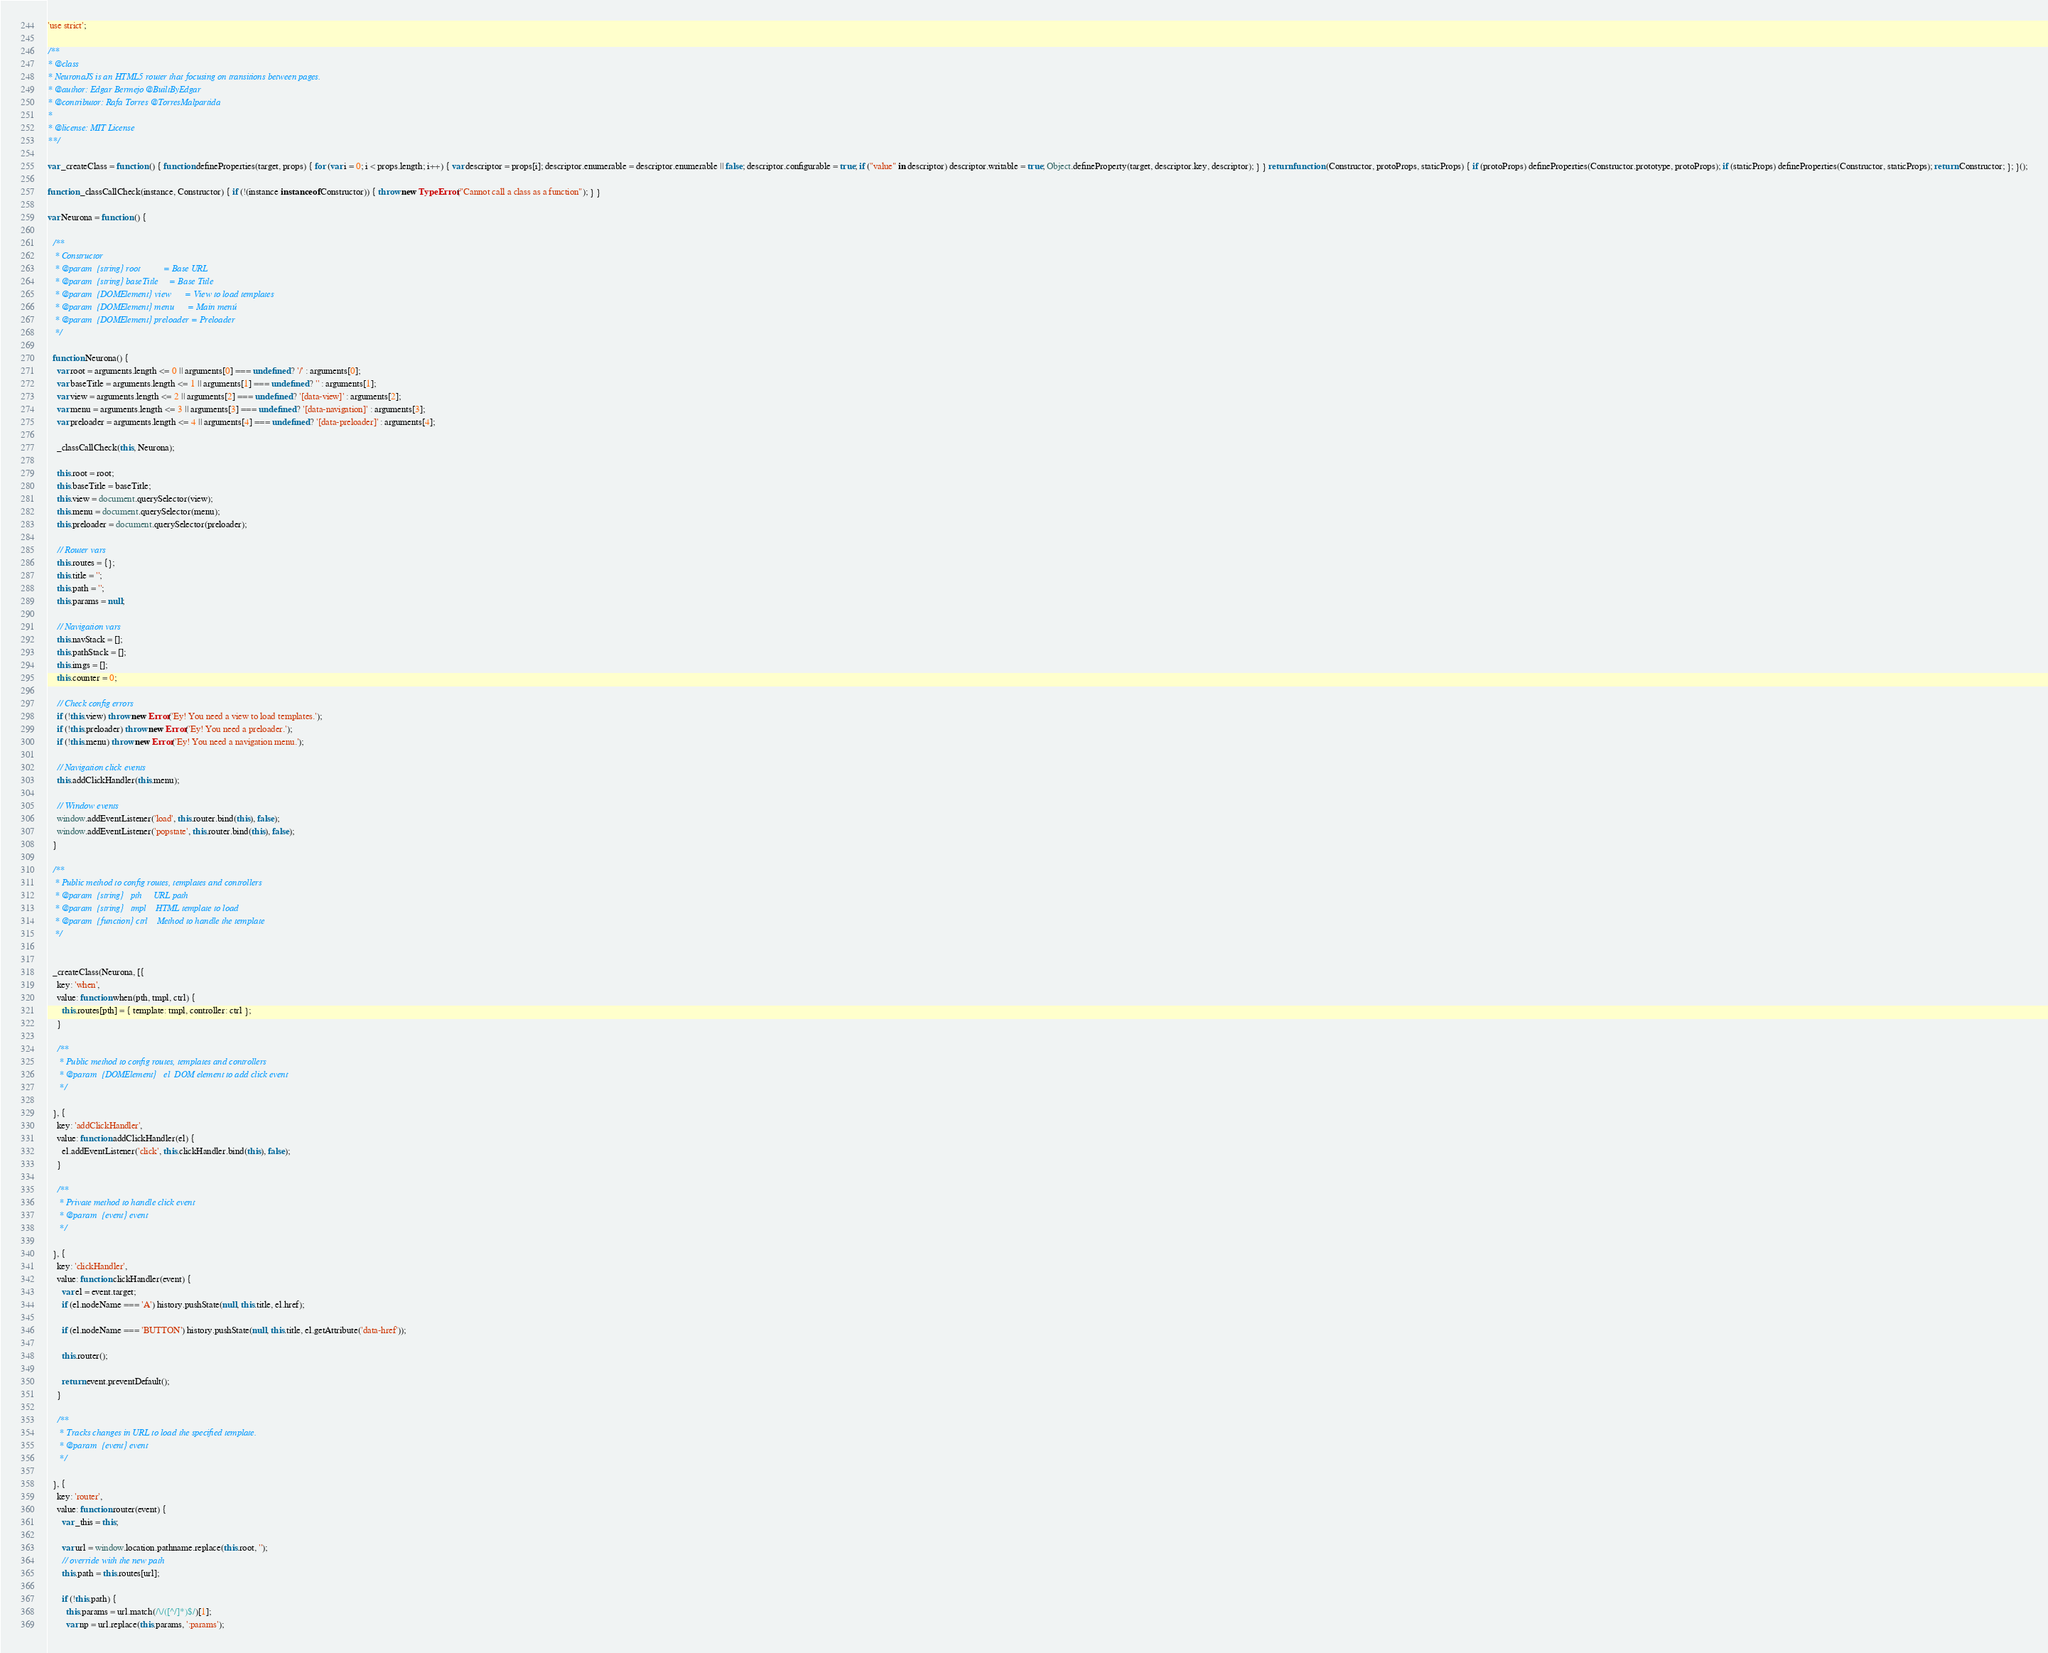Convert code to text. <code><loc_0><loc_0><loc_500><loc_500><_JavaScript_>
'use strict';

/**
* @class
* NeuronaJS is an HTML5 router that focusing on transitions between pages.
* @author: Edgar Bermejo @BuiltByEdgar
* @contributor: Rafa Torres @TorresMalpartida
*
* @license: MIT License
**/

var _createClass = function () { function defineProperties(target, props) { for (var i = 0; i < props.length; i++) { var descriptor = props[i]; descriptor.enumerable = descriptor.enumerable || false; descriptor.configurable = true; if ("value" in descriptor) descriptor.writable = true; Object.defineProperty(target, descriptor.key, descriptor); } } return function (Constructor, protoProps, staticProps) { if (protoProps) defineProperties(Constructor.prototype, protoProps); if (staticProps) defineProperties(Constructor, staticProps); return Constructor; }; }();

function _classCallCheck(instance, Constructor) { if (!(instance instanceof Constructor)) { throw new TypeError("Cannot call a class as a function"); } }

var Neurona = function () {

  /**
   * Constructor
   * @param  {string} root          = Base URL
   * @param  {string} baseTitle     = Base Title
   * @param  {DOMElement} view      = View to load templates
   * @param  {DOMElement} menu      = Main menú
   * @param  {DOMElement} preloader = Preloader
   */

  function Neurona() {
    var root = arguments.length <= 0 || arguments[0] === undefined ? '/' : arguments[0];
    var baseTitle = arguments.length <= 1 || arguments[1] === undefined ? '' : arguments[1];
    var view = arguments.length <= 2 || arguments[2] === undefined ? '[data-view]' : arguments[2];
    var menu = arguments.length <= 3 || arguments[3] === undefined ? '[data-navigation]' : arguments[3];
    var preloader = arguments.length <= 4 || arguments[4] === undefined ? '[data-preloader]' : arguments[4];

    _classCallCheck(this, Neurona);

    this.root = root;
    this.baseTitle = baseTitle;
    this.view = document.querySelector(view);
    this.menu = document.querySelector(menu);
    this.preloader = document.querySelector(preloader);

    // Router vars
    this.routes = {};
    this.title = '';
    this.path = '';
    this.params = null;

    // Navigation vars
    this.navStack = [];
    this.pathStack = [];
    this.imgs = [];
    this.counter = 0;

    // Check config errors
    if (!this.view) throw new Error('Ey! You need a view to load templates.');
    if (!this.preloader) throw new Error('Ey! You need a preloader.');
    if (!this.menu) throw new Error('Ey! You need a navigation menu.');

    // Navigation click events
    this.addClickHandler(this.menu);

    // Window events
    window.addEventListener('load', this.router.bind(this), false);
    window.addEventListener('popstate', this.router.bind(this), false);
  }

  /**
   * Public method to config routes, templates and controllers
   * @param  {string}   pth     URL path
   * @param  {string}   tmpl    HTML template to load
   * @param  {function} ctrl    Method to handle the template
   */


  _createClass(Neurona, [{
    key: 'when',
    value: function when(pth, tmpl, ctrl) {
      this.routes[pth] = { template: tmpl, controller: ctrl };
    }

    /**
     * Public method to config routes, templates and controllers
     * @param  {DOMElement}   el  DOM element to add click event
     */

  }, {
    key: 'addClickHandler',
    value: function addClickHandler(el) {
      el.addEventListener('click', this.clickHandler.bind(this), false);
    }

    /**
     * Private method to handle click event
     * @param  {event} event
     */

  }, {
    key: 'clickHandler',
    value: function clickHandler(event) {
      var el = event.target;
      if (el.nodeName === 'A') history.pushState(null, this.title, el.href);

      if (el.nodeName === 'BUTTON') history.pushState(null, this.title, el.getAttribute('data-href'));

      this.router();

      return event.preventDefault();
    }

    /**
     * Tracks changes in URL to load the specified template.
     * @param  {event} event
     */

  }, {
    key: 'router',
    value: function router(event) {
      var _this = this;

      var url = window.location.pathname.replace(this.root, '');
      // override with the new path
      this.path = this.routes[url];

      if (!this.path) {
        this.params = url.match(/\/([^/]*)$/)[1];
        var np = url.replace(this.params, ':params');</code> 